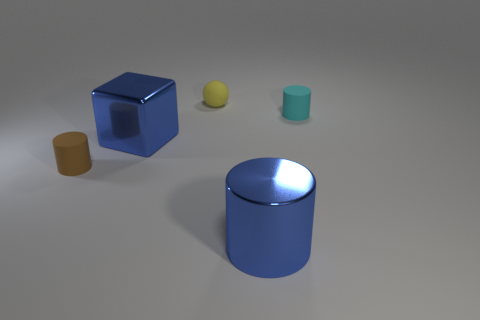Add 2 tiny yellow objects. How many objects exist? 7 Subtract all cylinders. How many objects are left? 2 Add 1 blue metallic objects. How many blue metallic objects are left? 3 Add 1 tiny brown rubber cylinders. How many tiny brown rubber cylinders exist? 2 Subtract 0 green cylinders. How many objects are left? 5 Subtract all big brown metallic balls. Subtract all brown cylinders. How many objects are left? 4 